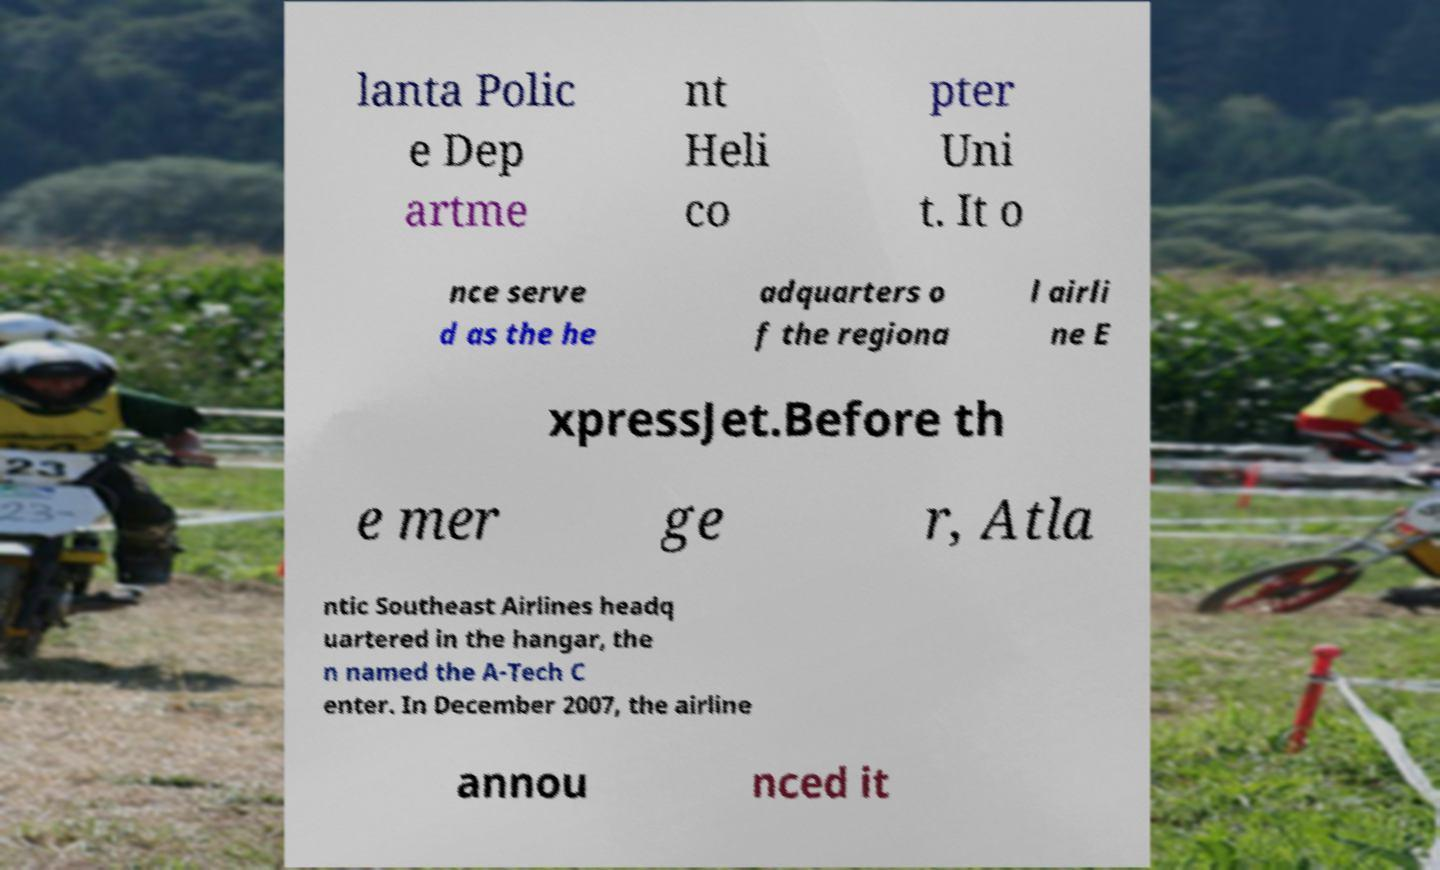I need the written content from this picture converted into text. Can you do that? lanta Polic e Dep artme nt Heli co pter Uni t. It o nce serve d as the he adquarters o f the regiona l airli ne E xpressJet.Before th e mer ge r, Atla ntic Southeast Airlines headq uartered in the hangar, the n named the A-Tech C enter. In December 2007, the airline annou nced it 